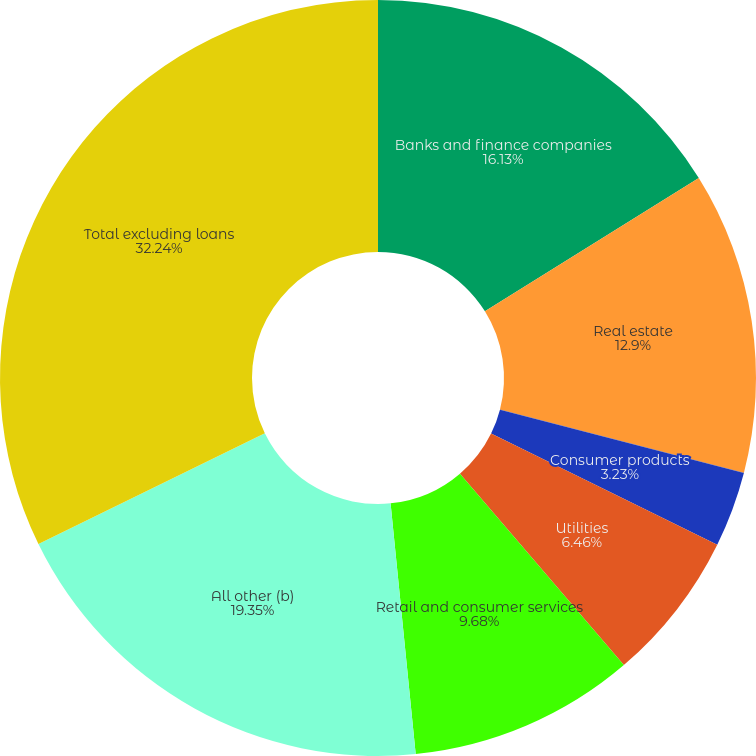Convert chart. <chart><loc_0><loc_0><loc_500><loc_500><pie_chart><fcel>Banks and finance companies<fcel>Real estate<fcel>State and municipal<fcel>Consumer products<fcel>Utilities<fcel>Retail and consumer services<fcel>All other (b)<fcel>Total excluding loans<nl><fcel>16.13%<fcel>12.9%<fcel>0.01%<fcel>3.23%<fcel>6.46%<fcel>9.68%<fcel>19.35%<fcel>32.24%<nl></chart> 